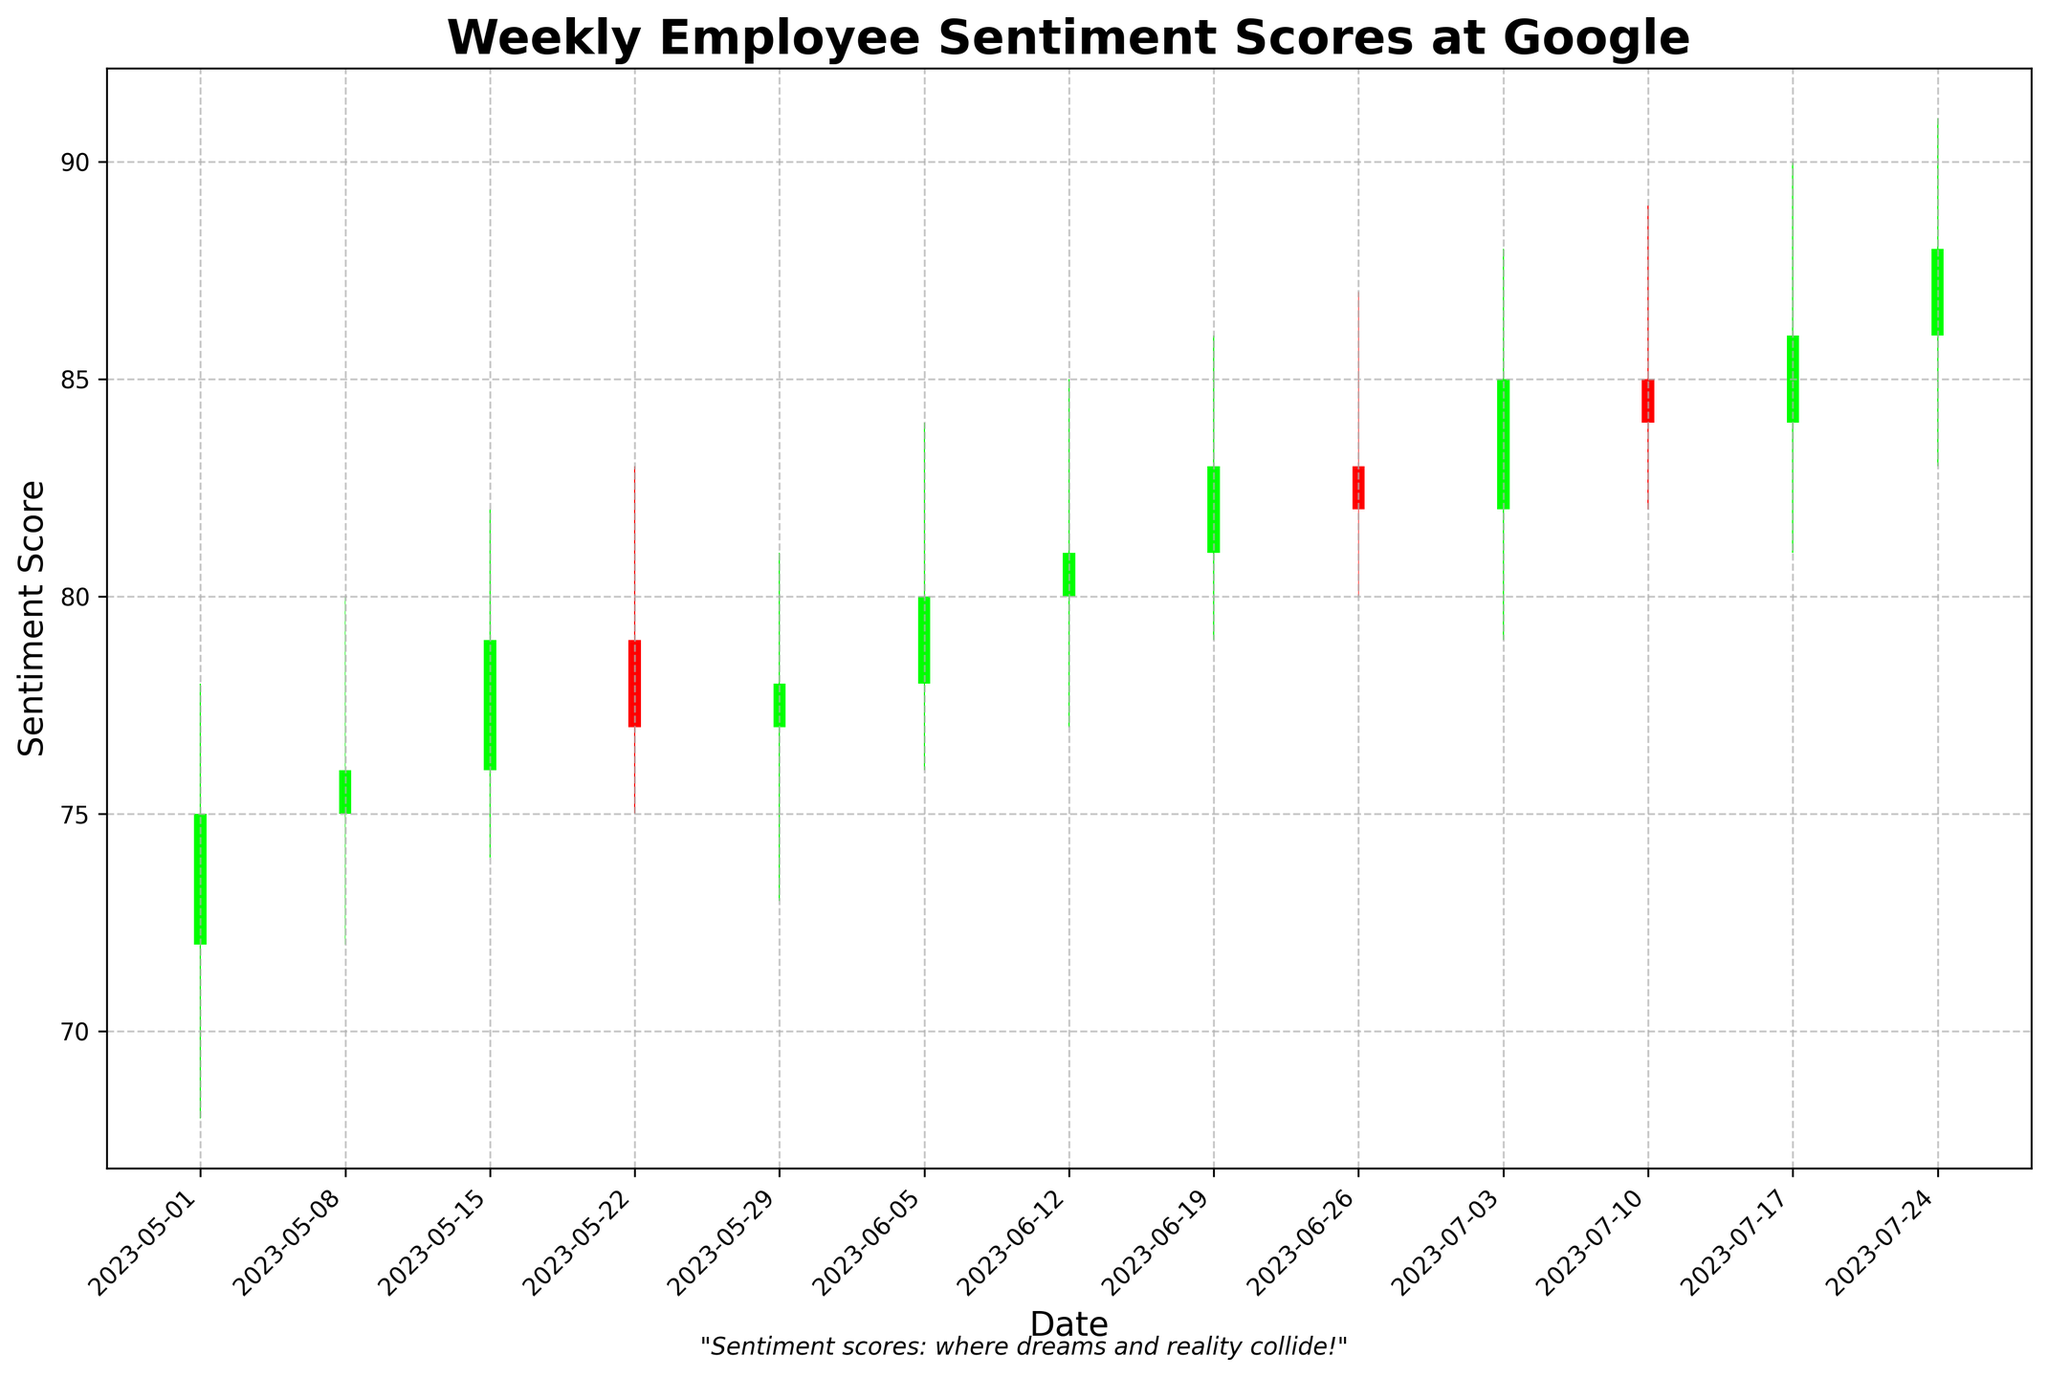What is the title of the chart? The title is the text at the top of the chart that summarizes what the chart is about.
Answer: "Weekly Employee Sentiment Scores at Google" What does the x-axis represent in this chart? The x-axis at the bottom of the chart represents the dates, specifically the weeks in which the employee sentiment scores were recorded.
Answer: Date Which color is used to represent an increase in employee sentiment score? The green bars represent an increase in sentiment scores where the close value is higher than the open value.
Answer: Green How many weeks of data are displayed in the chart? Count the number of data points along the x-axis. Each data point corresponds to one week.
Answer: 12 Which week recorded the highest closing sentiment score? Find the point where the top of the green or red bar reaches the highest value on the y-axis. The date at the bottom will indicate the week.
Answer: 2023-07-24 How does the sentiment score on 2023-05-29 compare to 2023-07-03? Compare the two closing sentiment scores for the respective dates by locating their positions vertically on the y-axis.
Answer: Lower on 2023-05-29 What is the difference between the highest and lowest sentiment scores in the week of 2023-06-26? For 2023-06-26, find the high and low values from the figure and subtract the low from the high.
Answer: 7 Which date had the smallest range of sentiment scores within the week? For each week, subtract the lowest value from the highest value. The week with the smallest difference is the one with the smallest range.
Answer: 2023-05-29 What weekly pattern do you observe in the sentiment scores from June to July 2023? Observe the trend and direction of the closing prices each week during these months.
Answer: Generally increasing What can be inferred from the humorous footnote of the chart? The footnote is an additional text that provides a light-hearted commentary about the sentiment scores.
Answer: "Sentiment scores: where dreams and reality collide!" 